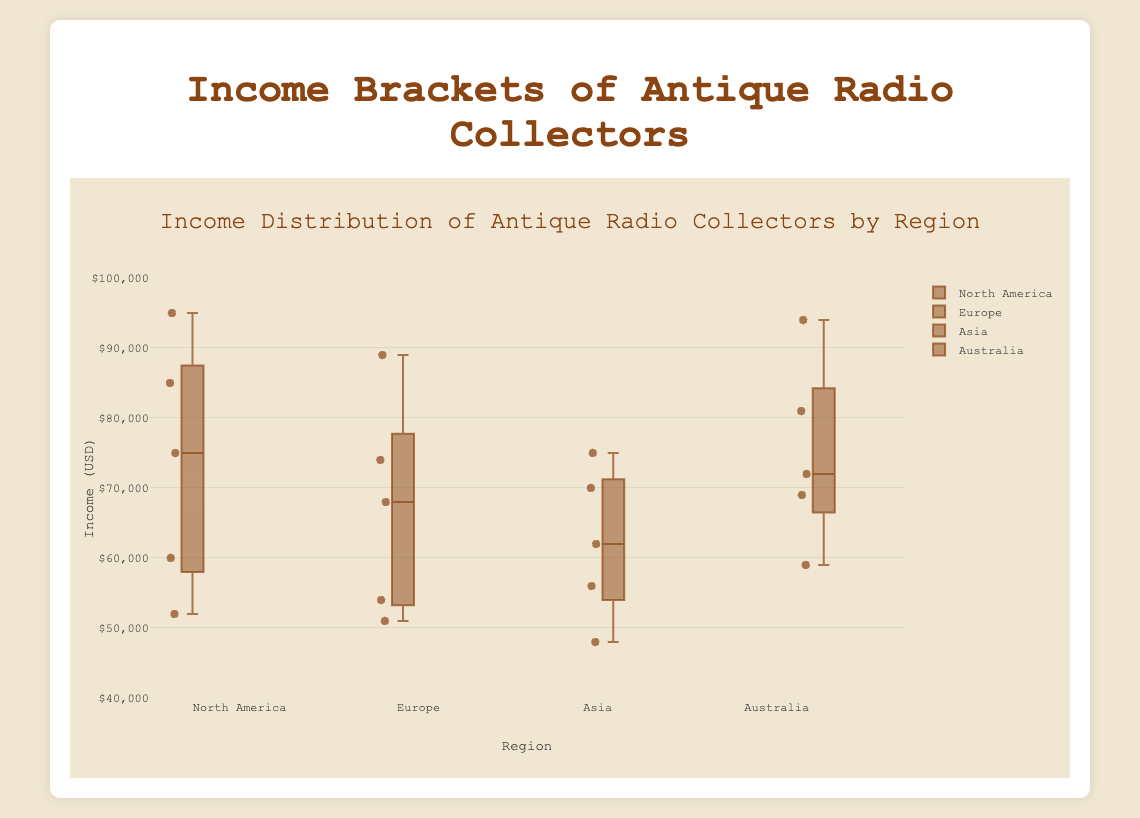What is the median income of antique radio collectors in Asia? Median income is the middle value when data is ordered. For Asia, order the incomes: 48000, 56000, 62000, 70000, 75000. The middle value is 62000
Answer: 62000 Which region has the highest median income for antique radio collectors? Calculate or identify the median incomes of each region from the box plots. North America (75000), Europe (68000), Asia (62000), Australia (69000). North America's median is highest
Answer: North America What is the range of incomes for collectors in Europe? Range is the difference between the maximum and minimum values. Europe's values are 51000 to 89000. Range = 89000 - 51000
Answer: 38000 Which region has the widest interquartile range (IQR) in income? IQR is the difference between Q3 and Q1. From the box plots, compare IQRs of all regions visually. North America appears to have the widest IQR.
Answer: North America Is the median income in North America greater than the median income in Australia? Compare the median values directly from the box plots. North America (75000) vs Australia (69000). 75000 > 69000
Answer: Yes What’s the lower quartile (Q1) of incomes for collectors in Australia? Q1 is the value below which 25% of the data falls. This is usually marked by the bottom of the box in the box plot. Australia's Q1 is 59000.
Answer: 59000 Are there any outliers visible in the box plot for Asia? Outliers are plotted as individual points beyond the whiskers. Review the plot for any such points in Asia. There are no points beyond the whiskers in Asia.
Answer: No Compare the highest income among collectors in Europe and Asia. Which is higher? Identify the upper whisker of the box plots for both regions. Europe’s highest income is 89000 and Asia’s is 75000. 89000 > 75000
Answer: Europe Describe the income distribution for Europe collectors. Review the box plot for Europe. The median is at 68000, IQR is between 54000 and 74000, min at 51000, max at 89000, no outliers.
Answer: Median at 68000, Q1 at 54000, Q3 at 74000, min at 51000, max at 89000 Which region has the lowest maximum income value among the collectors? Identify the top whisker values of all regions. Asia's maximum income value is 75000, which is the lowest among others.
Answer: Asia 